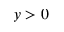Convert formula to latex. <formula><loc_0><loc_0><loc_500><loc_500>y > 0</formula> 